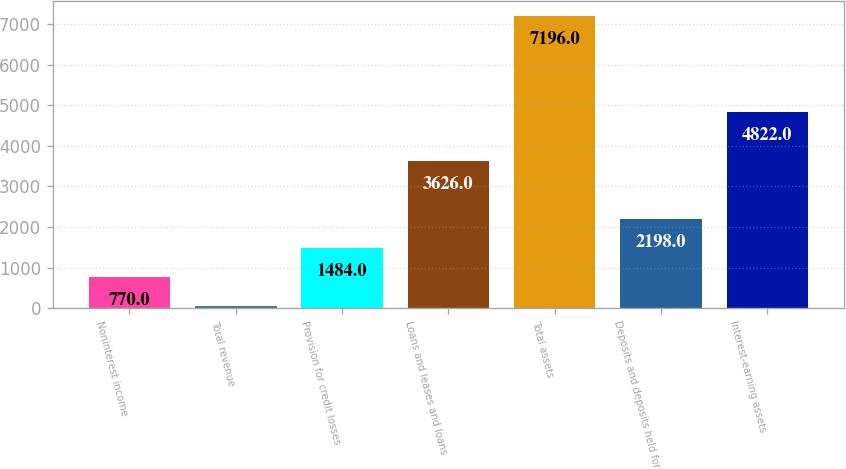Convert chart. <chart><loc_0><loc_0><loc_500><loc_500><bar_chart><fcel>Noninterest income<fcel>Total revenue<fcel>Provision for credit losses<fcel>Loans and leases and loans<fcel>Total assets<fcel>Deposits and deposits held for<fcel>Interest-earning assets<nl><fcel>770<fcel>56<fcel>1484<fcel>3626<fcel>7196<fcel>2198<fcel>4822<nl></chart> 